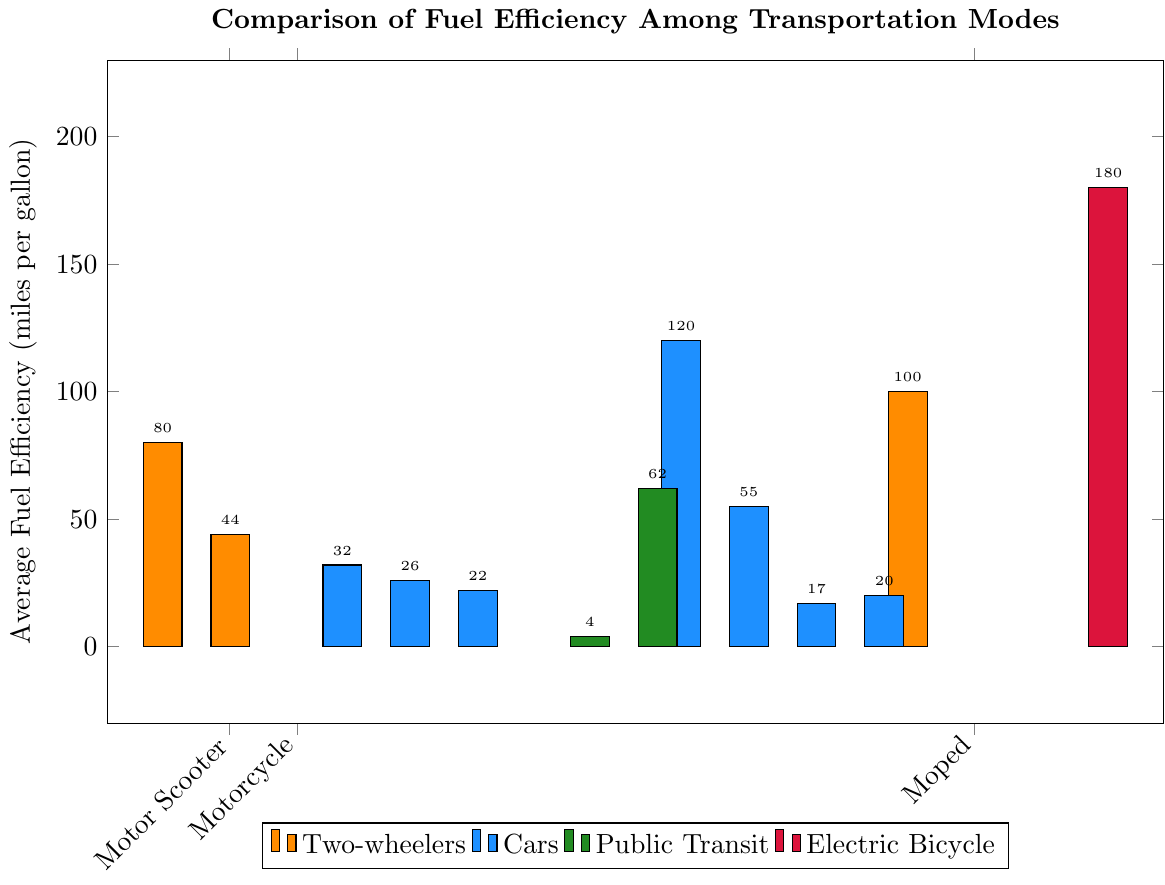Which mode of transportation has the highest fuel efficiency? The graph measures fuel efficiency in miles per gallon, and the tallest bar corresponds to the Electric Bicycle with 180 miles per gallon.
Answer: Electric Bicycle Which vehicle is more fuel-efficient, a Compact Car or a Midsize Car? By comparing the heights of the bars, the Compact Car has a higher fuel efficiency at 32 miles per gallon compared to the Midsize Car at 26 miles per gallon.
Answer: Compact Car How much more fuel-efficient is an Electric Car compared to a Hybrid Car? The Electric Car has a fuel efficiency of 120 miles per gallon, while the Hybrid Car has 55 miles per gallon. The difference is 120 - 55 = 65.
Answer: 65 miles per gallon Among the two-wheelers (Motor Scooter, Motorcycle, and Moped), which has the second-highest fuel efficiency? The fuel efficiencies are Motor Scooter (80), Motorcycle (44), and Moped (100). The second highest is the Motor Scooter with 80 miles per gallon.
Answer: Motor Scooter What is the average fuel efficiency of all transportation modes shown? Add the fuel efficiencies (80+44+32+26+22+4+62+120+55+17+20+100+180) and divide by the number of modes (13). The sum is 762, and dividing by 13 gives 58.62, approximately 59.
Answer: 59 miles per gallon By how much is the fuel efficiency of a City Bus lower than that of Light Rail? The City Bus has a fuel efficiency of 4 miles per gallon, and the Light Rail has 62 miles per gallon. The difference is 62 - 4 = 58.
Answer: 58 miles per gallon How does the fuel efficiency of an SUV compare to that of a Pickup Truck? The SUV is more fuel-efficient (22 miles per gallon) compared to the Pickup Truck (17 miles per gallon).
Answer: SUV is more fuel-efficient What color represents the bars for public transit modes? The bars for City Bus and Light Rail are represented in green color in the graph.
Answer: Green Which transportation mode(s) have infinite fuel efficiency, and why might this be the case? The graph indicates that Bicycle and Walking have infinite fuel efficiency because they do not use fuel.
Answer: Bicycle and Walking What is the difference in fuel efficiency between the most efficient electric vehicle and the least efficient vehicle? The most efficient electric vehicle, Electric Bicycle, has 180 miles per gallon, and the least efficient vehicle, City Bus, has 4 miles per gallon. The difference is 180 - 4 = 176.
Answer: 176 miles per gallon 